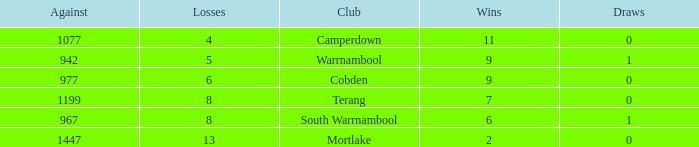What's the number of losses when the wins were more than 11 and had 0 draws? 0.0. 